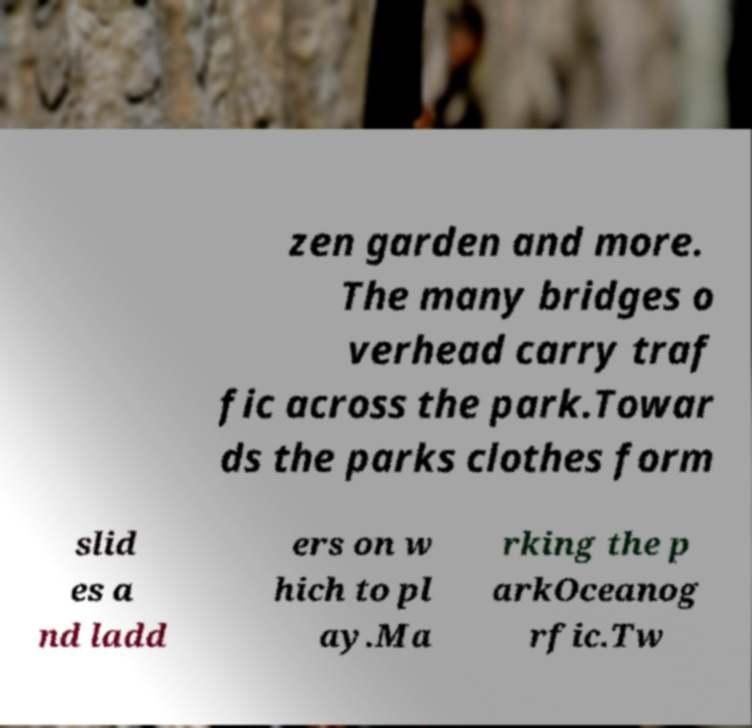Please identify and transcribe the text found in this image. zen garden and more. The many bridges o verhead carry traf fic across the park.Towar ds the parks clothes form slid es a nd ladd ers on w hich to pl ay.Ma rking the p arkOceanog rfic.Tw 